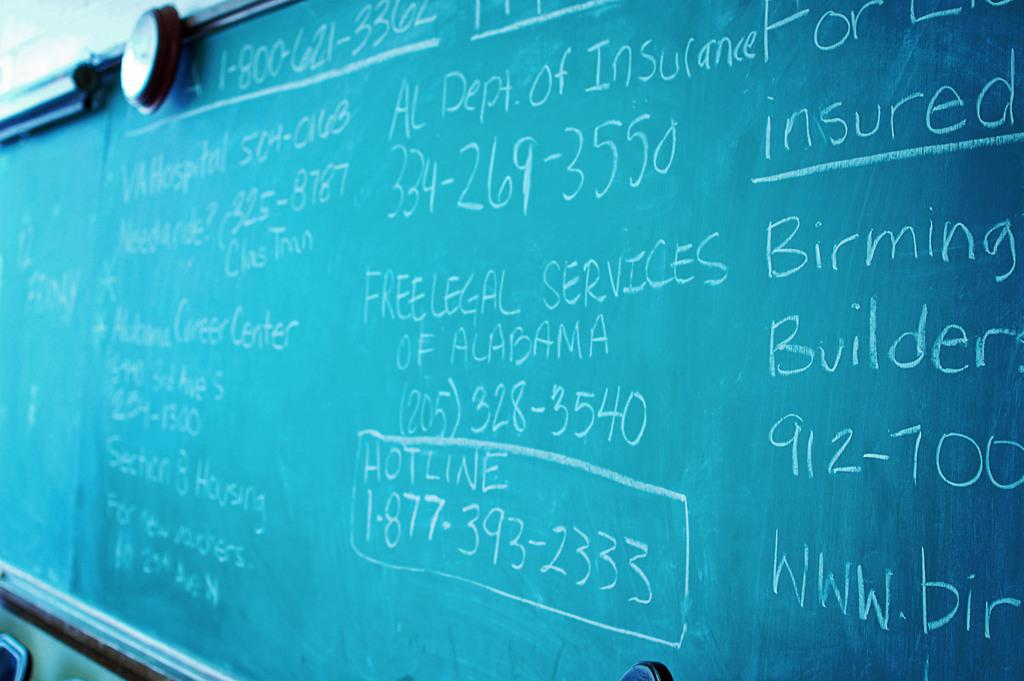<image>
Provide a brief description of the given image. White chalk written on a green chalkbaord with hotline number 